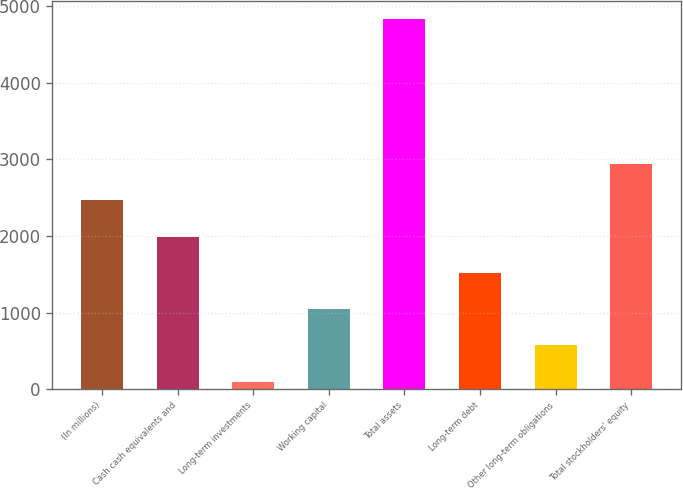<chart> <loc_0><loc_0><loc_500><loc_500><bar_chart><fcel>(In millions)<fcel>Cash cash equivalents and<fcel>Long-term investments<fcel>Working capital<fcel>Total assets<fcel>Long-term debt<fcel>Other long-term obligations<fcel>Total stockholders' equity<nl><fcel>2461.5<fcel>1988.6<fcel>97<fcel>1042.8<fcel>4826<fcel>1515.7<fcel>569.9<fcel>2934.4<nl></chart> 